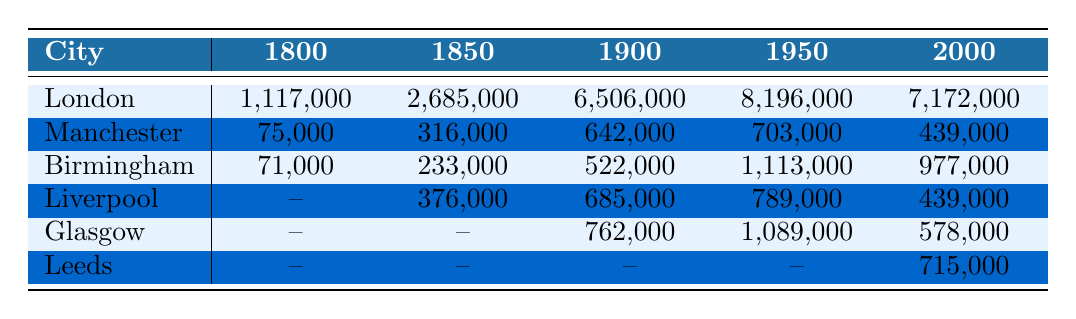What was the population of London in 1850? The table shows that the population of London in 1850 is listed as 2,685,000.
Answer: 2,685,000 Which city had the highest population growth from 1800 to 1950? To determine this, we calculate the difference in population for each city between the two years. For London: 8,196,000 - 1,117,000 = 7,079,000. For Manchester: 703,000 - 75,000 = 628,000. For Birmingham: 1,113,000 - 71,000 = 1,042,000. For Liverpool: 789,000 - 376,000 = 413,000. Glasgow: 1,089,000 - 0 = 1,089,000. London had the highest growth of 7,079,000.
Answer: London Is the population of Manchester in 2000 greater than that in 1900? The population of Manchester in 2000 is 439,000, while in 1900 it was 642,000. Therefore, 439,000 is less than 642,000, making the statement false.
Answer: No What was the average population across these major cities in 1900? We calculate the average population in 1900 by adding the populations of each listed city: London (6,506,000) + Manchester (642,000) + Birmingham (522,000) + Liverpool (685,000) + Glasgow (762,000) = 9,117,000. We then divide by the number of cities (5): 9,117,000 / 5 = 1,823,400.
Answer: 1,823,400 Did any city experience a decline in population from 1950 to 2000? We check the population values for each city from 1950 to 2000. London: 8,196,000 to 7,172,000 (decline), Manchester: 703,000 to 439,000 (decline), Birmingham: 1,113,000 to 977,000 (decline), Liverpool: 789,000 to 439,000 (decline), and Glasgow: 1,089,000 to 578,000 (decline). Since all cities listed show a decline, the answer is yes.
Answer: Yes 